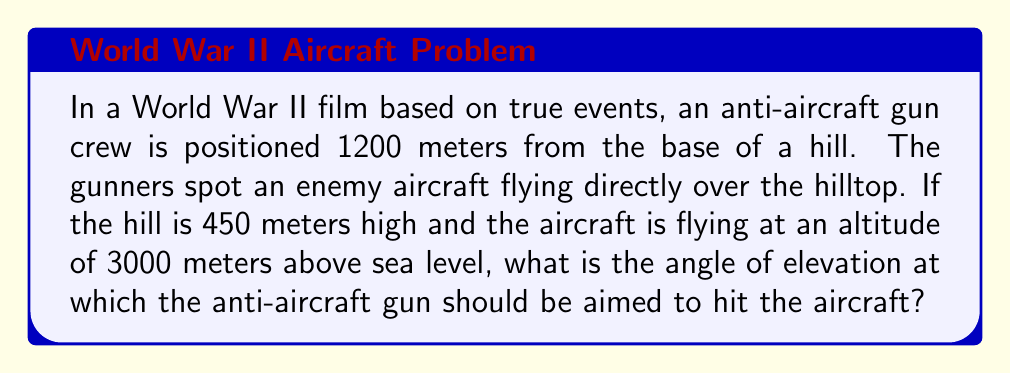Give your solution to this math problem. Let's approach this step-by-step:

1) First, let's visualize the scenario:

[asy]
import geometry;

size(200);

pair A = (0,0);
pair B = (120,0);
pair C = (120,45);
pair D = (120,300);

draw(A--B--D--A);
draw(B--C,dashed);

label("Gun", A, SW);
label("Base of hill", B, S);
label("Top of hill", C, E);
label("Aircraft", D, E);

label("1200 m", (A+B)/2, S);
label("450 m", (B+C)/2, E);
label("2550 m", (C+D)/2, E);
label("$\theta$", A, NE);
[/asy]

2) We need to find the angle $\theta$ at the gun position.

3) We can use the tangent function, which is opposite over adjacent:

   $$\tan(\theta) = \frac{\text{opposite}}{\text{adjacent}}$$

4) The opposite side is the total height of the aircraft minus the height of the hill:
   
   $3000 - 450 = 2550$ meters

5) The adjacent side is the distance to the base of the hill:
   
   $1200$ meters

6) Plugging these into our tangent equation:

   $$\tan(\theta) = \frac{2550}{1200}$$

7) To find $\theta$, we need to use the inverse tangent (arctan or $\tan^{-1}$):

   $$\theta = \tan^{-1}(\frac{2550}{1200})$$

8) Using a calculator or computer:

   $$\theta \approx 64.8^\circ$$

This is the angle of elevation at which the anti-aircraft gun should be aimed.
Answer: $64.8^\circ$ 